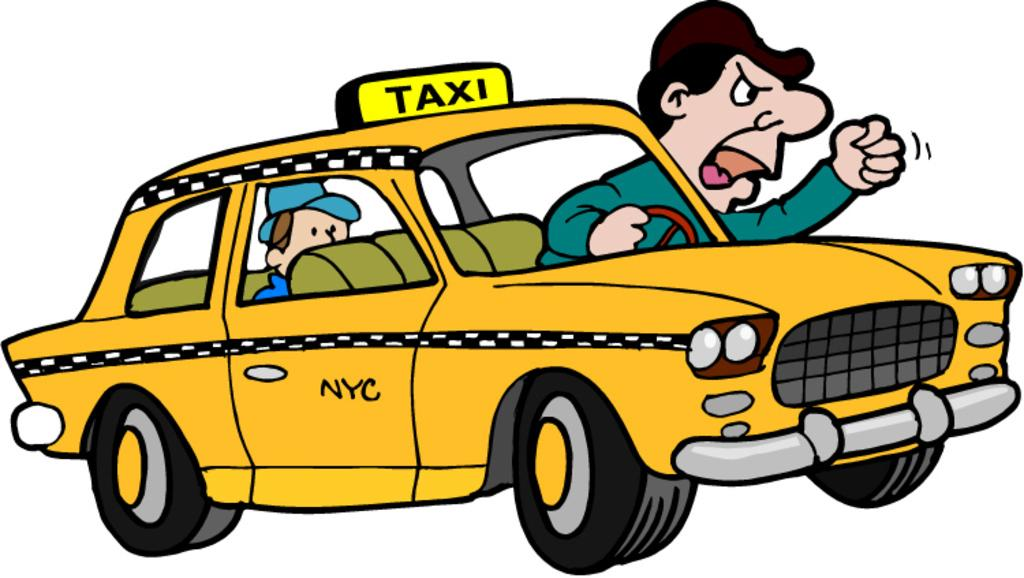Provide a one-sentence caption for the provided image. Someone created an unflattering cartoon of a New York City taxi, irate taxi driver, and rider!. 